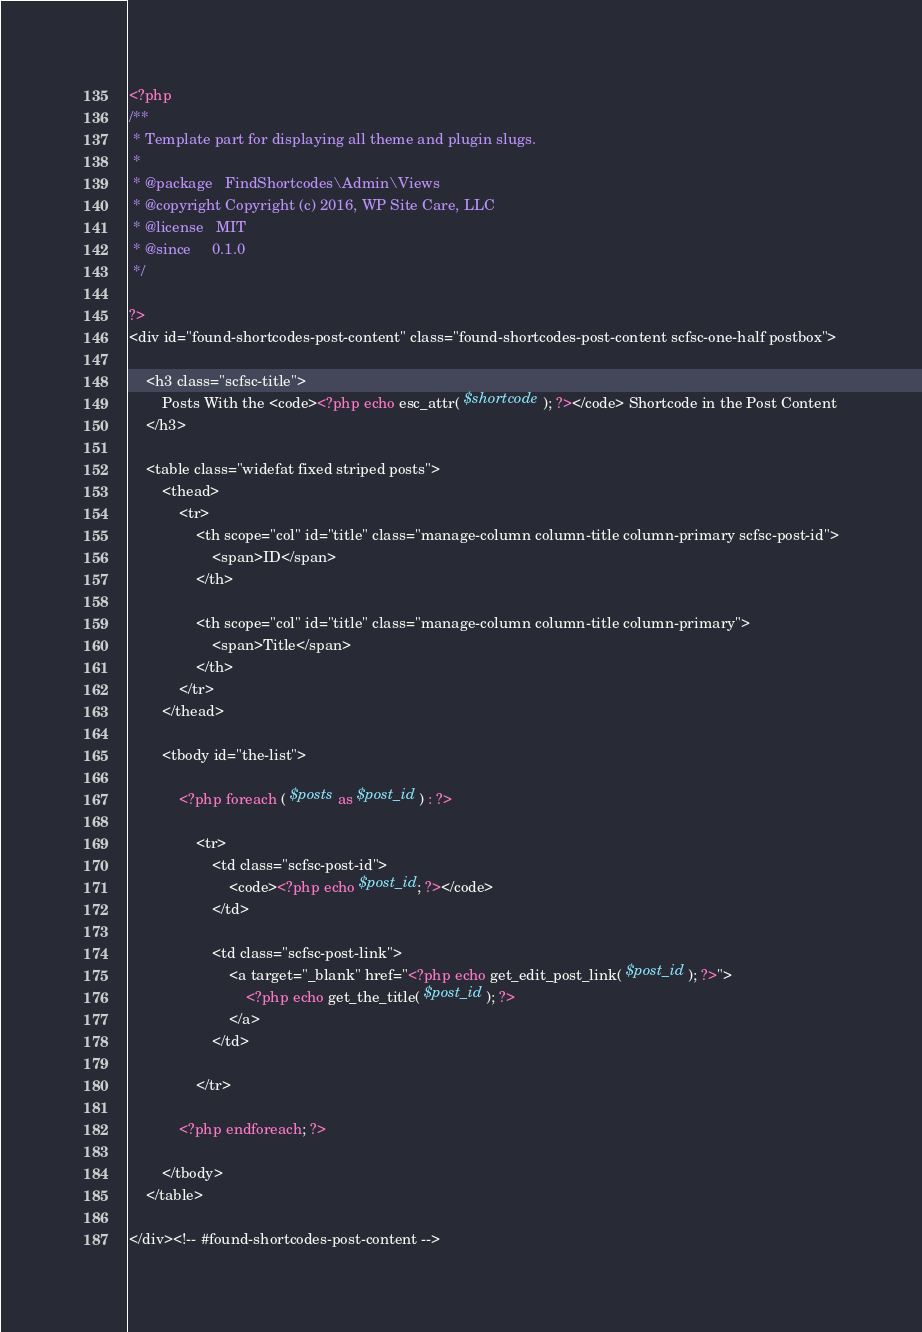Convert code to text. <code><loc_0><loc_0><loc_500><loc_500><_PHP_><?php
/**
 * Template part for displaying all theme and plugin slugs.
 *
 * @package   FindShortcodes\Admin\Views
 * @copyright Copyright (c) 2016, WP Site Care, LLC
 * @license   MIT
 * @since     0.1.0
 */

?>
<div id="found-shortcodes-post-content" class="found-shortcodes-post-content scfsc-one-half postbox">

	<h3 class="scfsc-title">
		Posts With the <code><?php echo esc_attr( $shortcode ); ?></code> Shortcode in the Post Content
	</h3>

	<table class="widefat fixed striped posts">
		<thead>
			<tr>
				<th scope="col" id="title" class="manage-column column-title column-primary scfsc-post-id">
					<span>ID</span>
				</th>

				<th scope="col" id="title" class="manage-column column-title column-primary">
					<span>Title</span>
				</th>
			</tr>
		</thead>

		<tbody id="the-list">

			<?php foreach ( $posts as $post_id ) : ?>

				<tr>
					<td class="scfsc-post-id">
						<code><?php echo $post_id; ?></code>
					</td>

					<td class="scfsc-post-link">
						<a target="_blank" href="<?php echo get_edit_post_link( $post_id ); ?>">
							<?php echo get_the_title( $post_id ); ?>
						</a>
					</td>

				</tr>

			<?php endforeach; ?>

		</tbody>
	</table>

</div><!-- #found-shortcodes-post-content -->
</code> 